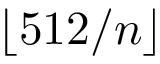Convert formula to latex. <formula><loc_0><loc_0><loc_500><loc_500>\lfloor 5 1 2 / n \rfloor</formula> 